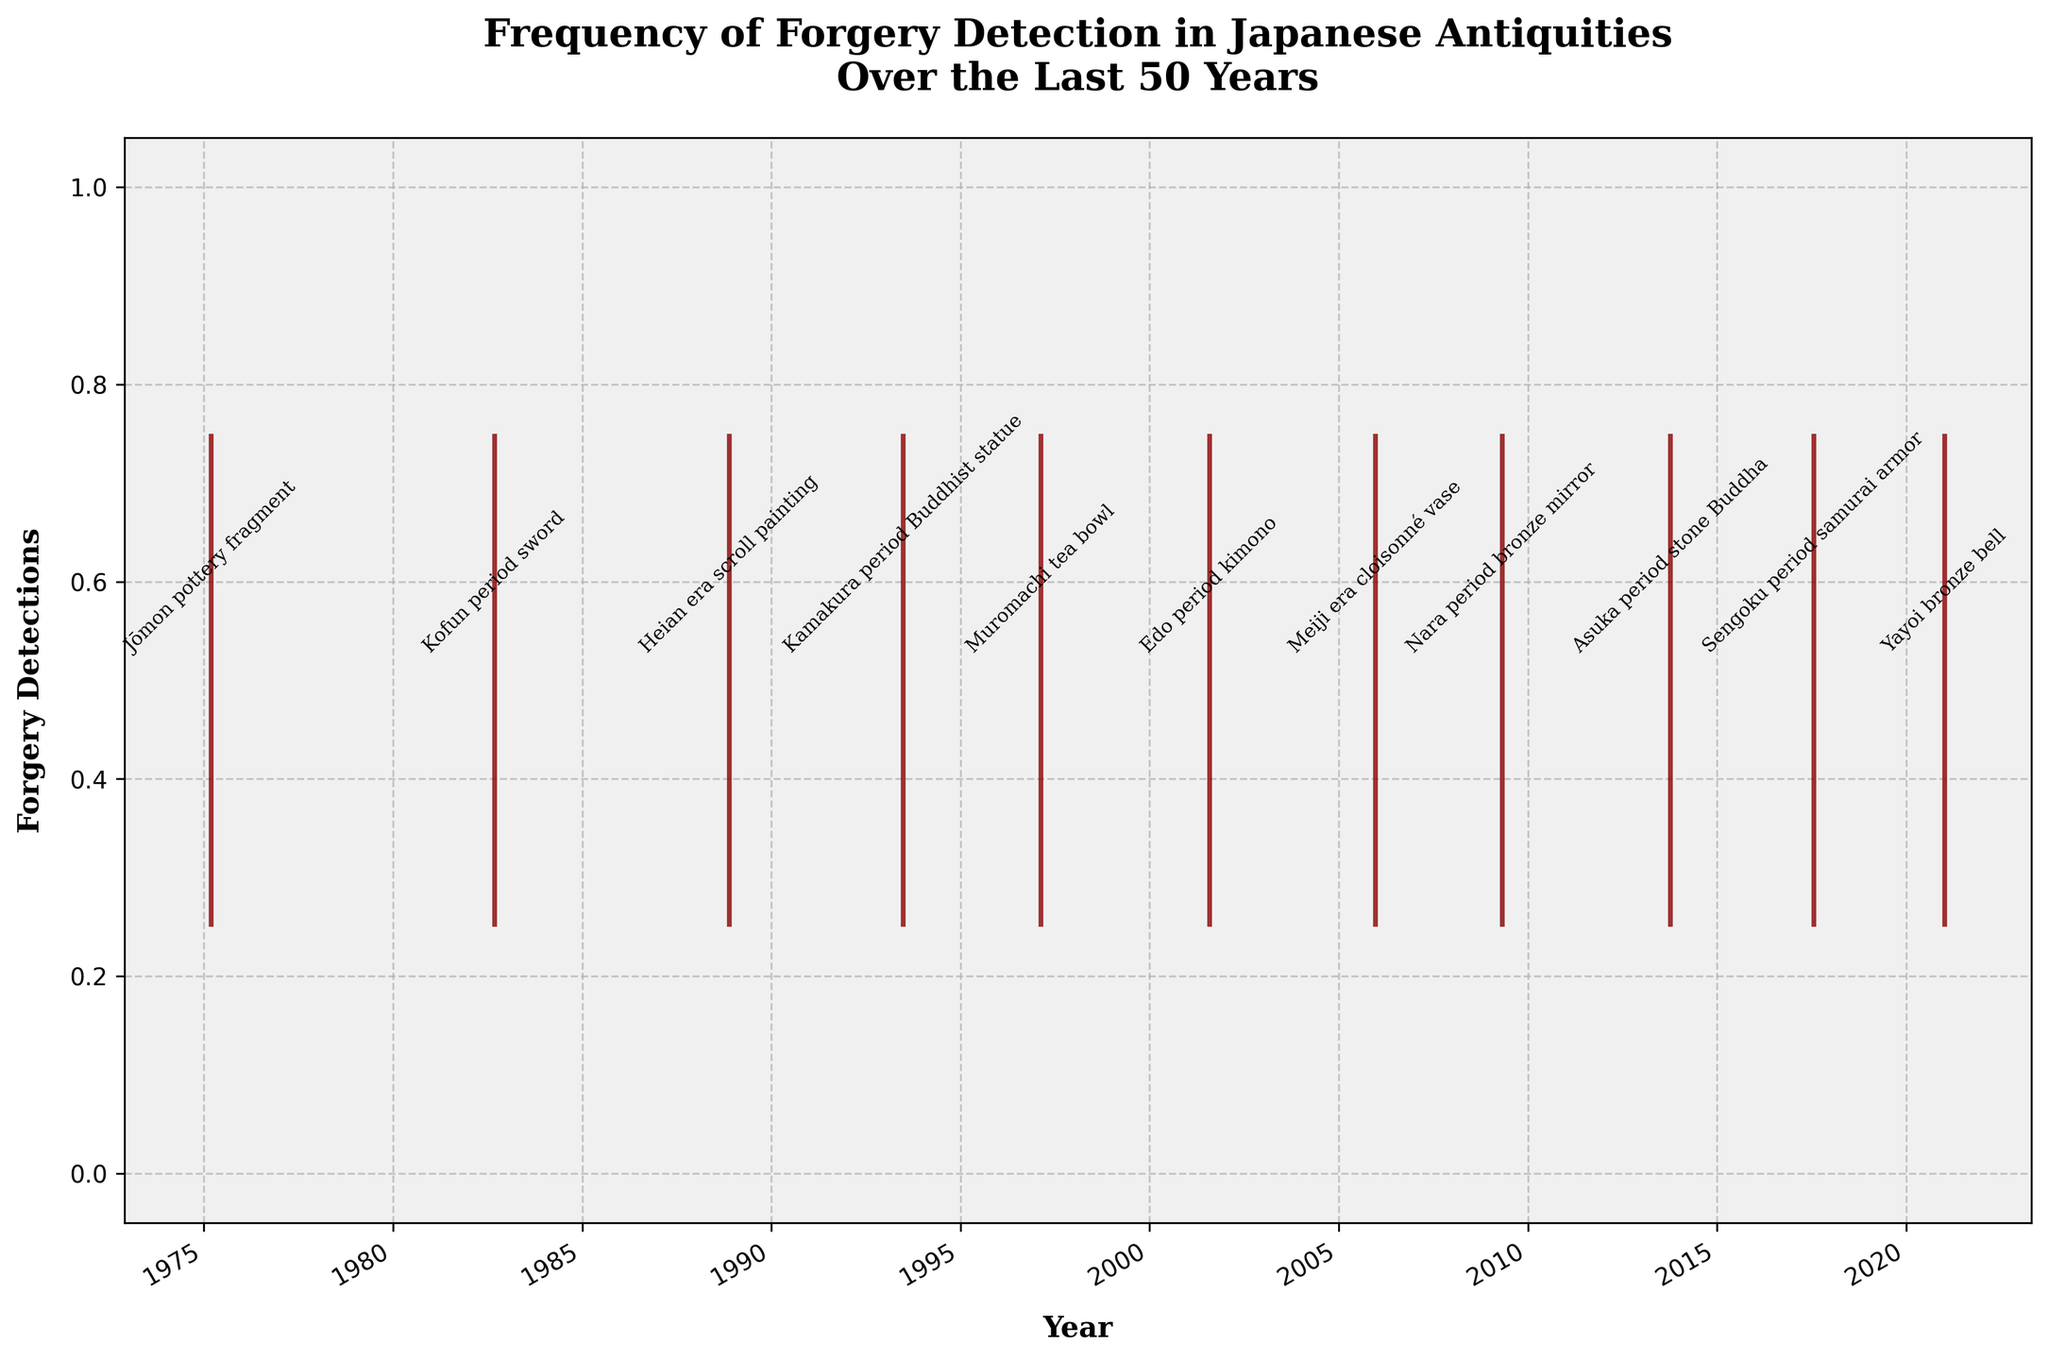Which year has the earliest forgery detection? By looking at the plot and identifying the leftmost data point on the x-axis, we can see that the earliest forgery detection occurred.
Answer: 1975 How many forgery detections are there in total? Counting each red marker on the event plot gives us the total number of forgery detections.
Answer: 11 What is the time gap between the detection of the Kamakura period Buddhist statue and the Edo period kimono? First, locate the red markers for both artifacts on the plot. The Kamakura period Buddhist statue was detected in 1993, and the Edo period kimono was detected in 2001. The time gap is 2001 - 1993 = 8 years.
Answer: 8 years What year had the most recent forgery detection? By identifying the rightmost data point on the x-axis, we see that the most recent forgery detection occurred.
Answer: 2021 How many forgery detections occurred before the year 2000? Count the number of red markers on the event plot that appear on the left side of the year 2000. By counting, we find that there are detections in 1975, 1982, 1988, 1993, and 1997. This gives us a total of 5 detections.
Answer: 5 Which period's artifact had a forgery detection in 2009? By looking at the plot around the year 2009, we can read the label near the corresponding red marker, which identifies the artifact.
Answer: Nara period bronze mirror Is there any year where more than one forgery detection occurred? By examining the plot closely, we notice each year only has one red marker, so there is no year with more than one forgery detection.
Answer: No Between which two consecutive forgery detections is the largest time gap? Reviewing the plot, we observe the time intervals between each pair of consecutive markers. The largest gap is between the detection in 2021 and the previous one in 2017, which is a 4-year gap.
Answer: 2017 and 2021 What's the average number of years between all forgery detections? First, calculate the total number of years from the first to the last forgery detection (2021 - 1975 = 46 years). Since there are 11 forgery detections, we have 10 intervals. Divide the total years by the number of intervals: 46 / 10 = 4.6 years.
Answer: 4.6 years 